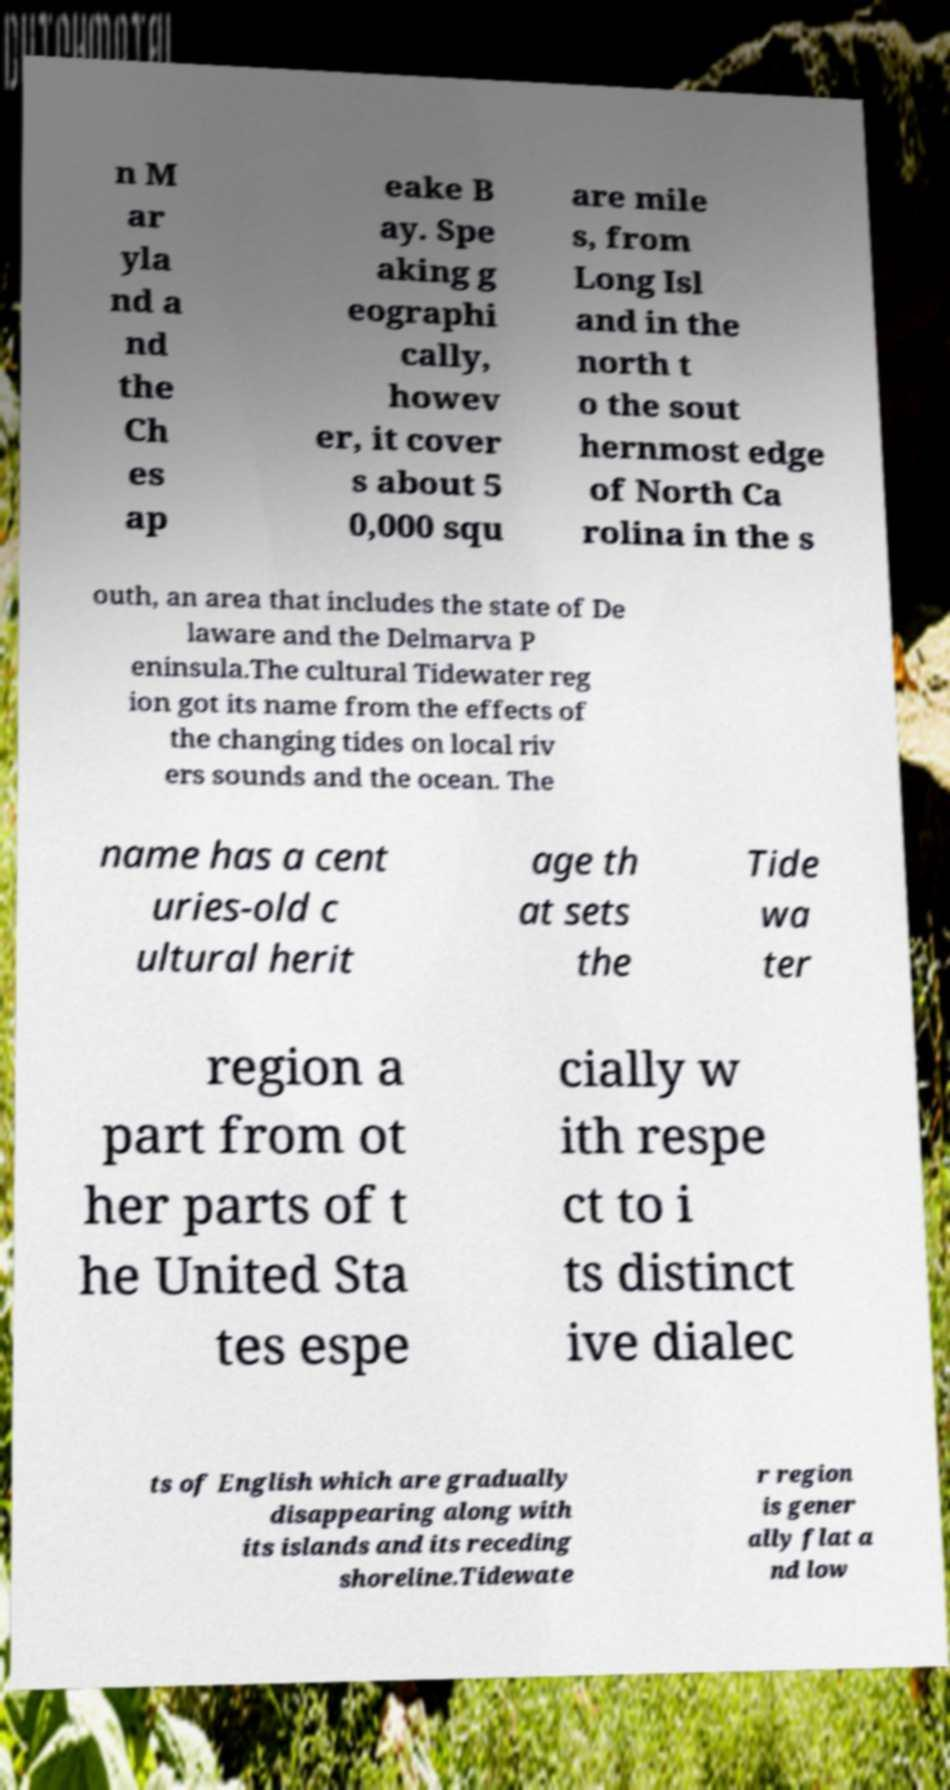Could you extract and type out the text from this image? n M ar yla nd a nd the Ch es ap eake B ay. Spe aking g eographi cally, howev er, it cover s about 5 0,000 squ are mile s, from Long Isl and in the north t o the sout hernmost edge of North Ca rolina in the s outh, an area that includes the state of De laware and the Delmarva P eninsula.The cultural Tidewater reg ion got its name from the effects of the changing tides on local riv ers sounds and the ocean. The name has a cent uries-old c ultural herit age th at sets the Tide wa ter region a part from ot her parts of t he United Sta tes espe cially w ith respe ct to i ts distinct ive dialec ts of English which are gradually disappearing along with its islands and its receding shoreline.Tidewate r region is gener ally flat a nd low 